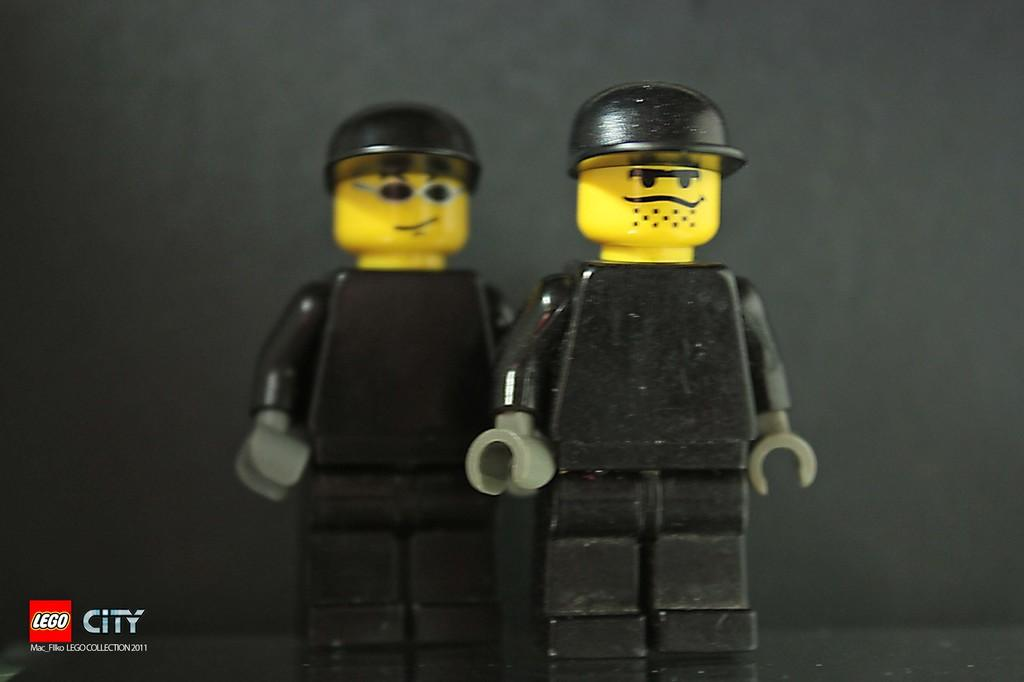What objects can be seen in the image? There are toys in the image. Is there any text or marking in the image? Yes, there is a watermark in the left bottom corner of the image. What can be seen in the background of the image? There is a wall in the background of the image. What type of learning is taking place in the image? There is no indication of learning or any educational activity in the image. 